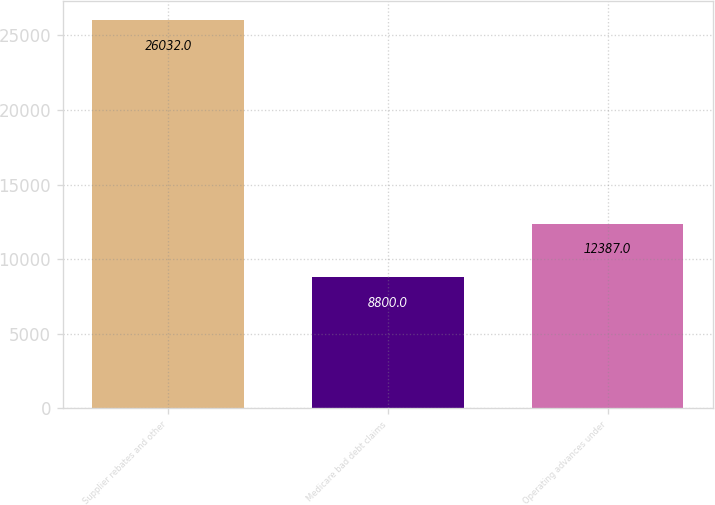Convert chart. <chart><loc_0><loc_0><loc_500><loc_500><bar_chart><fcel>Supplier rebates and other<fcel>Medicare bad debt claims<fcel>Operating advances under<nl><fcel>26032<fcel>8800<fcel>12387<nl></chart> 